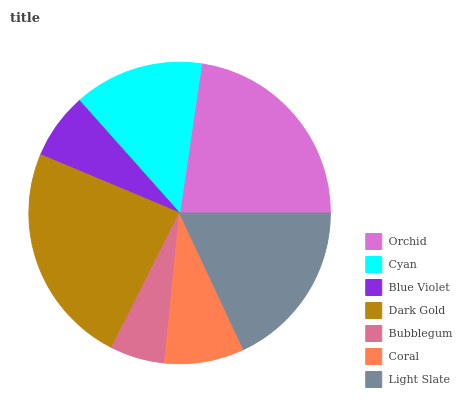Is Bubblegum the minimum?
Answer yes or no. Yes. Is Dark Gold the maximum?
Answer yes or no. Yes. Is Cyan the minimum?
Answer yes or no. No. Is Cyan the maximum?
Answer yes or no. No. Is Orchid greater than Cyan?
Answer yes or no. Yes. Is Cyan less than Orchid?
Answer yes or no. Yes. Is Cyan greater than Orchid?
Answer yes or no. No. Is Orchid less than Cyan?
Answer yes or no. No. Is Cyan the high median?
Answer yes or no. Yes. Is Cyan the low median?
Answer yes or no. Yes. Is Dark Gold the high median?
Answer yes or no. No. Is Blue Violet the low median?
Answer yes or no. No. 